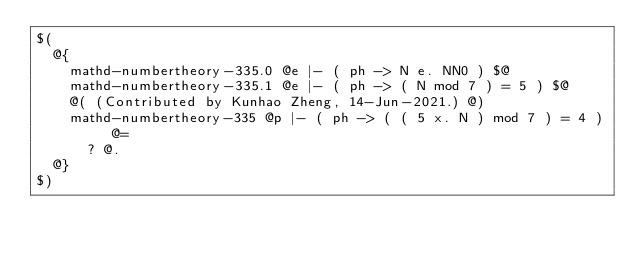Convert code to text. <code><loc_0><loc_0><loc_500><loc_500><_ObjectiveC_>$(
  @{
    mathd-numbertheory-335.0 @e |- ( ph -> N e. NN0 ) $@
    mathd-numbertheory-335.1 @e |- ( ph -> ( N mod 7 ) = 5 ) $@
    @( (Contributed by Kunhao Zheng, 14-Jun-2021.) @)
    mathd-numbertheory-335 @p |- ( ph -> ( ( 5 x. N ) mod 7 ) = 4 ) @=
      ? @.
  @}
$)
</code> 